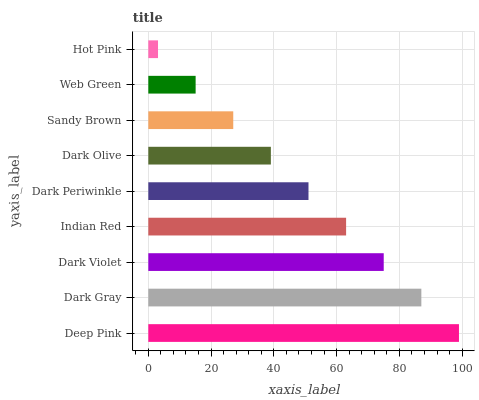Is Hot Pink the minimum?
Answer yes or no. Yes. Is Deep Pink the maximum?
Answer yes or no. Yes. Is Dark Gray the minimum?
Answer yes or no. No. Is Dark Gray the maximum?
Answer yes or no. No. Is Deep Pink greater than Dark Gray?
Answer yes or no. Yes. Is Dark Gray less than Deep Pink?
Answer yes or no. Yes. Is Dark Gray greater than Deep Pink?
Answer yes or no. No. Is Deep Pink less than Dark Gray?
Answer yes or no. No. Is Dark Periwinkle the high median?
Answer yes or no. Yes. Is Dark Periwinkle the low median?
Answer yes or no. Yes. Is Sandy Brown the high median?
Answer yes or no. No. Is Deep Pink the low median?
Answer yes or no. No. 